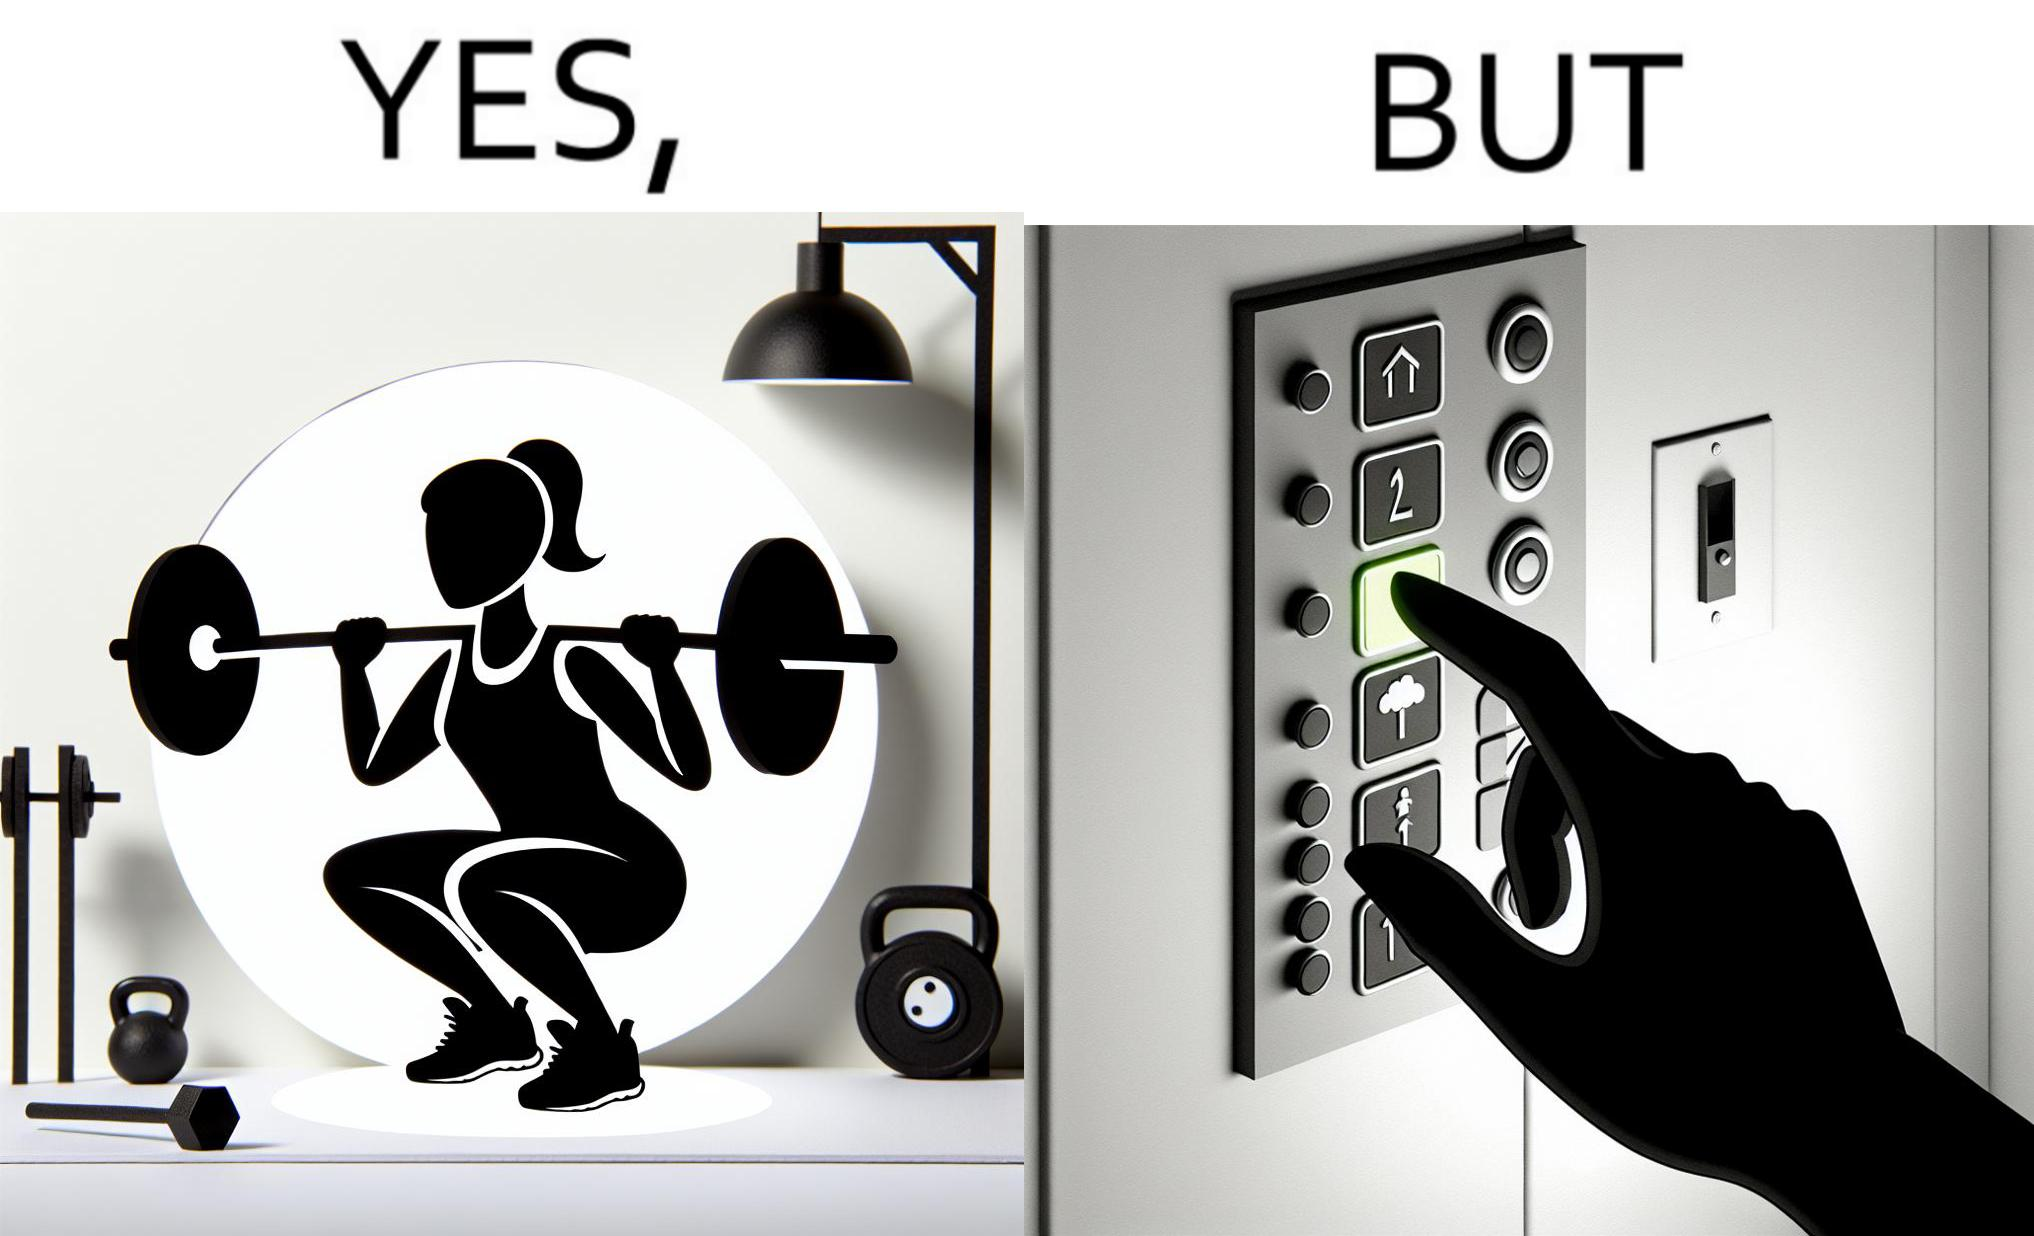Does this image contain satire or humor? Yes, this image is satirical. 